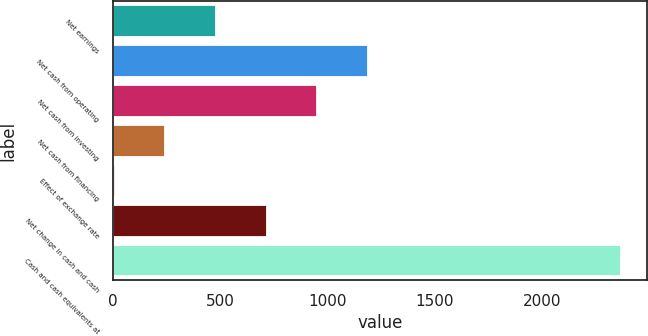<chart> <loc_0><loc_0><loc_500><loc_500><bar_chart><fcel>Net earnings<fcel>Net cash from operating<fcel>Net cash from investing<fcel>Net cash from financing<fcel>Effect of exchange rate<fcel>Net change in cash and cash<fcel>Cash and cash equivalents at<nl><fcel>480.2<fcel>1188.5<fcel>952.4<fcel>244.1<fcel>8<fcel>716.3<fcel>2369<nl></chart> 